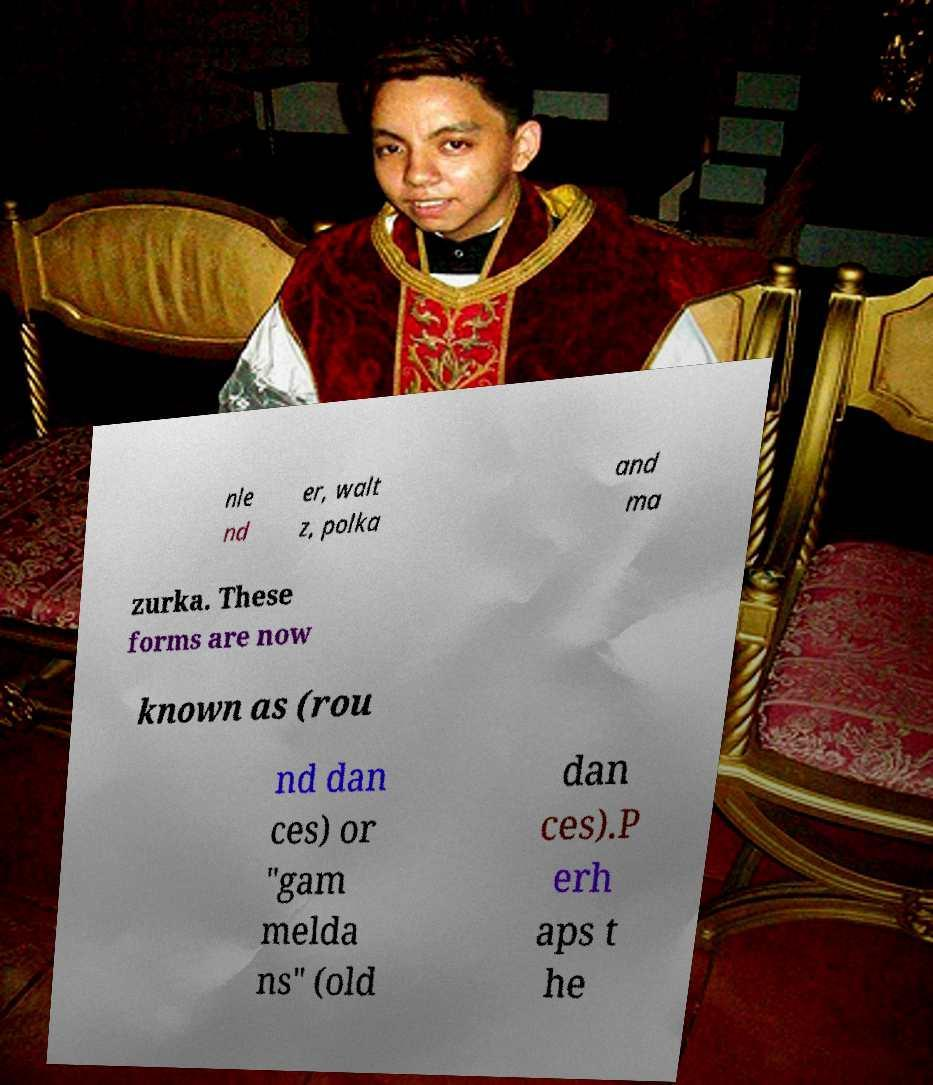Can you accurately transcribe the text from the provided image for me? nle nd er, walt z, polka and ma zurka. These forms are now known as (rou nd dan ces) or "gam melda ns" (old dan ces).P erh aps t he 